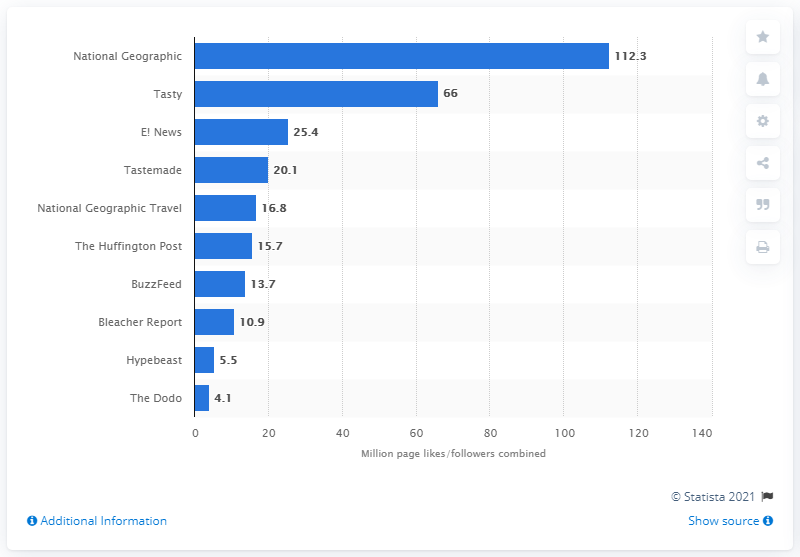Highlight a few significant elements in this photo. In March 2016, E! News had 25.4 followers. In March 2016, National Geographic had a total of 112.3 page likes and followers. 